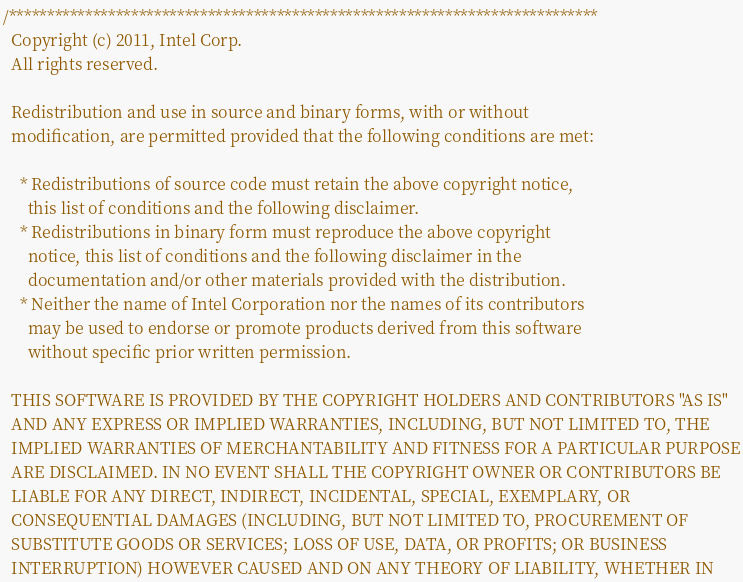Convert code to text. <code><loc_0><loc_0><loc_500><loc_500><_C_>/*****************************************************************************
  Copyright (c) 2011, Intel Corp.
  All rights reserved.

  Redistribution and use in source and binary forms, with or without
  modification, are permitted provided that the following conditions are met:

    * Redistributions of source code must retain the above copyright notice,
      this list of conditions and the following disclaimer.
    * Redistributions in binary form must reproduce the above copyright
      notice, this list of conditions and the following disclaimer in the
      documentation and/or other materials provided with the distribution.
    * Neither the name of Intel Corporation nor the names of its contributors
      may be used to endorse or promote products derived from this software
      without specific prior written permission.

  THIS SOFTWARE IS PROVIDED BY THE COPYRIGHT HOLDERS AND CONTRIBUTORS "AS IS"
  AND ANY EXPRESS OR IMPLIED WARRANTIES, INCLUDING, BUT NOT LIMITED TO, THE
  IMPLIED WARRANTIES OF MERCHANTABILITY AND FITNESS FOR A PARTICULAR PURPOSE
  ARE DISCLAIMED. IN NO EVENT SHALL THE COPYRIGHT OWNER OR CONTRIBUTORS BE
  LIABLE FOR ANY DIRECT, INDIRECT, INCIDENTAL, SPECIAL, EXEMPLARY, OR
  CONSEQUENTIAL DAMAGES (INCLUDING, BUT NOT LIMITED TO, PROCUREMENT OF
  SUBSTITUTE GOODS OR SERVICES; LOSS OF USE, DATA, OR PROFITS; OR BUSINESS
  INTERRUPTION) HOWEVER CAUSED AND ON ANY THEORY OF LIABILITY, WHETHER IN</code> 